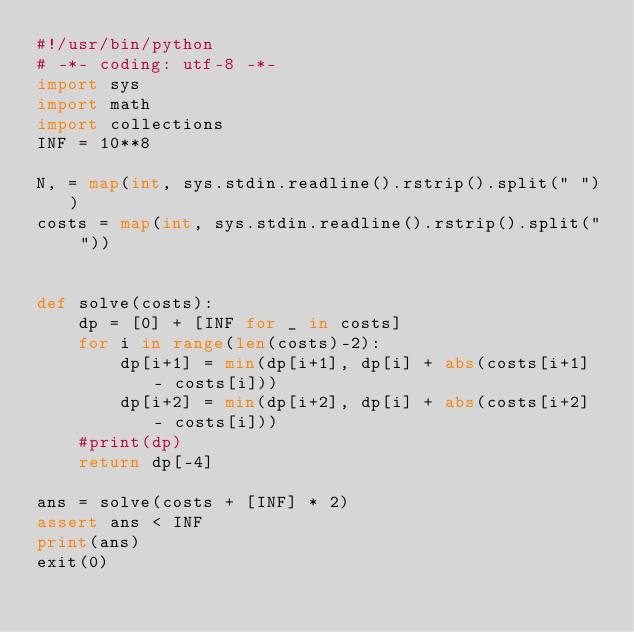Convert code to text. <code><loc_0><loc_0><loc_500><loc_500><_Python_>#!/usr/bin/python
# -*- coding: utf-8 -*-
import sys
import math
import collections
INF = 10**8

N, = map(int, sys.stdin.readline().rstrip().split(" "))
costs = map(int, sys.stdin.readline().rstrip().split(" "))


def solve(costs):
    dp = [0] + [INF for _ in costs]
    for i in range(len(costs)-2):
        dp[i+1] = min(dp[i+1], dp[i] + abs(costs[i+1] - costs[i]))
        dp[i+2] = min(dp[i+2], dp[i] + abs(costs[i+2] - costs[i]))
    #print(dp)
    return dp[-4]

ans = solve(costs + [INF] * 2)
assert ans < INF
print(ans)
exit(0)
</code> 